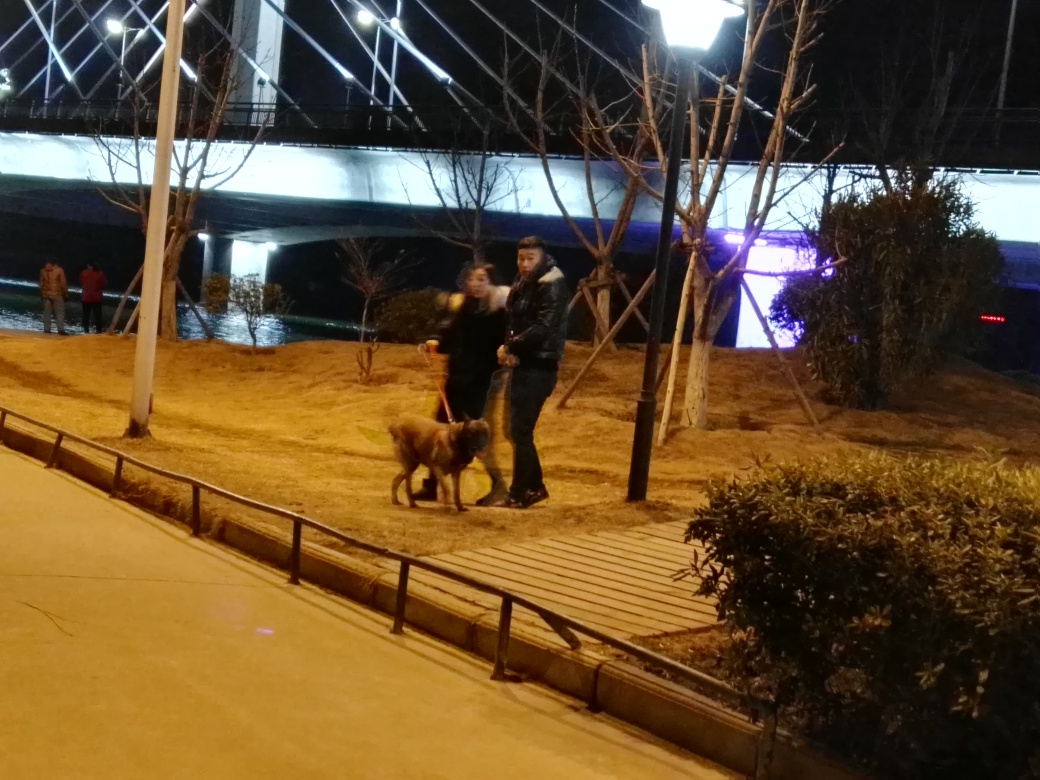Are the people in the image clear? While the individuals in the image are recognizable, the overall clarity is compromised due to what appears to be low lighting conditions and potential motion blur, affecting the sharpness of the subjects. 